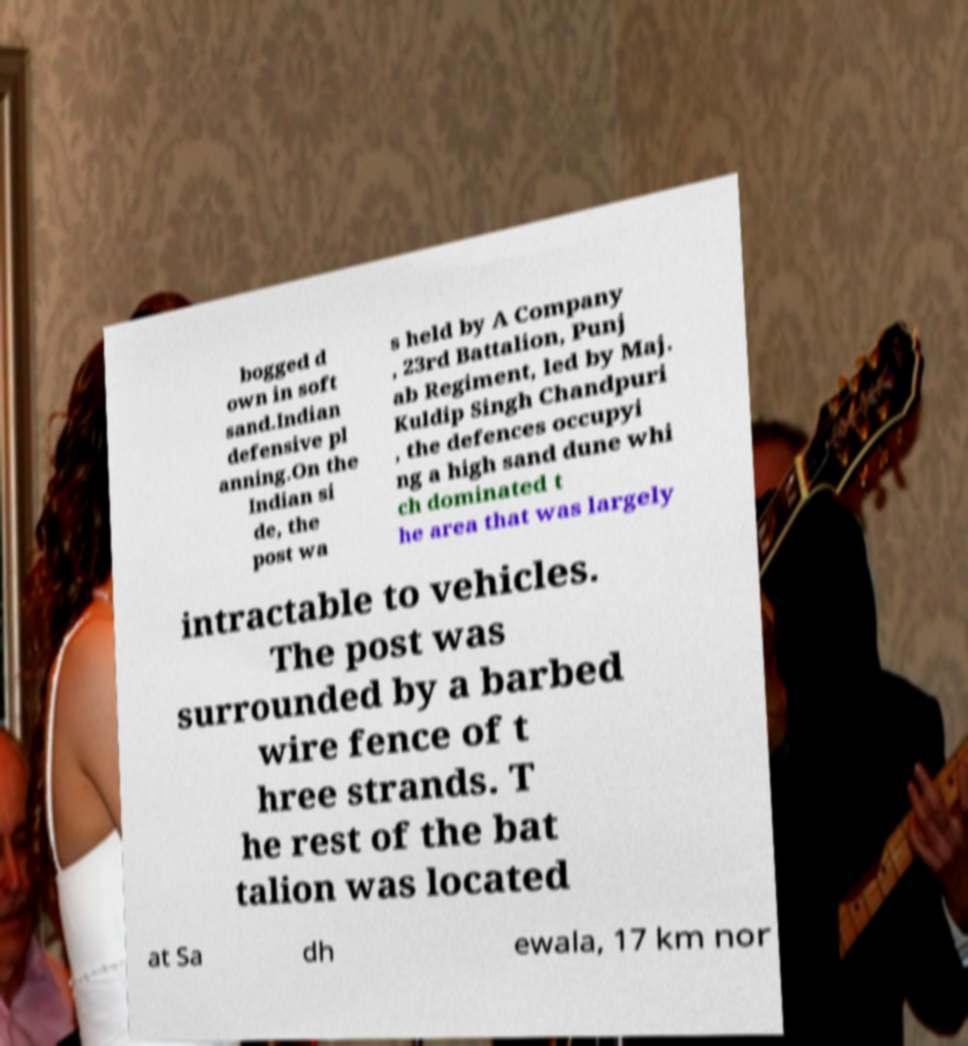There's text embedded in this image that I need extracted. Can you transcribe it verbatim? bogged d own in soft sand.Indian defensive pl anning.On the Indian si de, the post wa s held by A Company , 23rd Battalion, Punj ab Regiment, led by Maj. Kuldip Singh Chandpuri , the defences occupyi ng a high sand dune whi ch dominated t he area that was largely intractable to vehicles. The post was surrounded by a barbed wire fence of t hree strands. T he rest of the bat talion was located at Sa dh ewala, 17 km nor 